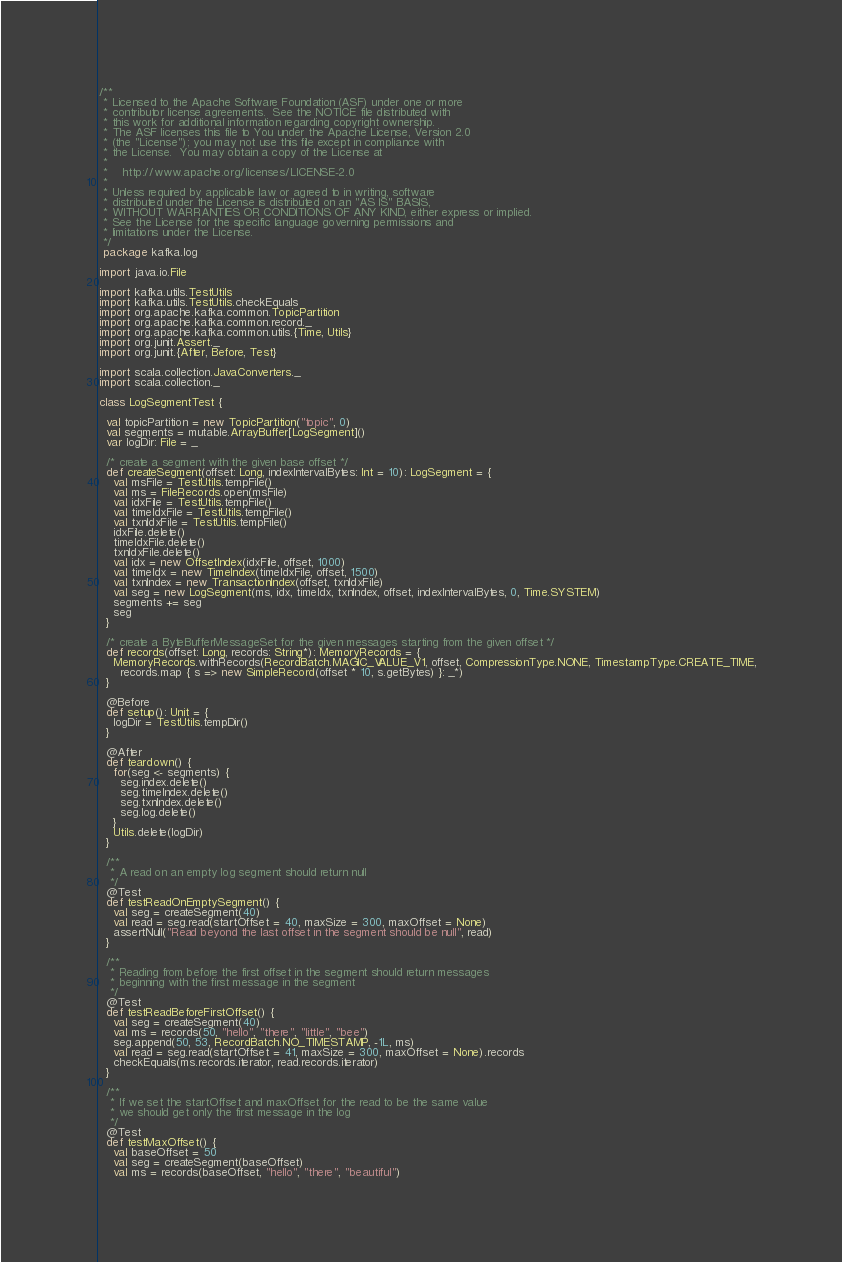Convert code to text. <code><loc_0><loc_0><loc_500><loc_500><_Scala_>/**
 * Licensed to the Apache Software Foundation (ASF) under one or more
 * contributor license agreements.  See the NOTICE file distributed with
 * this work for additional information regarding copyright ownership.
 * The ASF licenses this file to You under the Apache License, Version 2.0
 * (the "License"); you may not use this file except in compliance with
 * the License.  You may obtain a copy of the License at
 *
 *    http://www.apache.org/licenses/LICENSE-2.0
 *
 * Unless required by applicable law or agreed to in writing, software
 * distributed under the License is distributed on an "AS IS" BASIS,
 * WITHOUT WARRANTIES OR CONDITIONS OF ANY KIND, either express or implied.
 * See the License for the specific language governing permissions and
 * limitations under the License.
 */
 package kafka.log

import java.io.File

import kafka.utils.TestUtils
import kafka.utils.TestUtils.checkEquals
import org.apache.kafka.common.TopicPartition
import org.apache.kafka.common.record._
import org.apache.kafka.common.utils.{Time, Utils}
import org.junit.Assert._
import org.junit.{After, Before, Test}

import scala.collection.JavaConverters._
import scala.collection._

class LogSegmentTest {
  
  val topicPartition = new TopicPartition("topic", 0)
  val segments = mutable.ArrayBuffer[LogSegment]()
  var logDir: File = _

  /* create a segment with the given base offset */
  def createSegment(offset: Long, indexIntervalBytes: Int = 10): LogSegment = {
    val msFile = TestUtils.tempFile()
    val ms = FileRecords.open(msFile)
    val idxFile = TestUtils.tempFile()
    val timeIdxFile = TestUtils.tempFile()
    val txnIdxFile = TestUtils.tempFile()
    idxFile.delete()
    timeIdxFile.delete()
    txnIdxFile.delete()
    val idx = new OffsetIndex(idxFile, offset, 1000)
    val timeIdx = new TimeIndex(timeIdxFile, offset, 1500)
    val txnIndex = new TransactionIndex(offset, txnIdxFile)
    val seg = new LogSegment(ms, idx, timeIdx, txnIndex, offset, indexIntervalBytes, 0, Time.SYSTEM)
    segments += seg
    seg
  }
  
  /* create a ByteBufferMessageSet for the given messages starting from the given offset */
  def records(offset: Long, records: String*): MemoryRecords = {
    MemoryRecords.withRecords(RecordBatch.MAGIC_VALUE_V1, offset, CompressionType.NONE, TimestampType.CREATE_TIME,
      records.map { s => new SimpleRecord(offset * 10, s.getBytes) }: _*)
  }

  @Before
  def setup(): Unit = {
    logDir = TestUtils.tempDir()
  }

  @After
  def teardown() {
    for(seg <- segments) {
      seg.index.delete()
      seg.timeIndex.delete()
      seg.txnIndex.delete()
      seg.log.delete()
    }
    Utils.delete(logDir)
  }

  /**
   * A read on an empty log segment should return null
   */
  @Test
  def testReadOnEmptySegment() {
    val seg = createSegment(40)
    val read = seg.read(startOffset = 40, maxSize = 300, maxOffset = None)
    assertNull("Read beyond the last offset in the segment should be null", read)
  }

  /**
   * Reading from before the first offset in the segment should return messages
   * beginning with the first message in the segment
   */
  @Test
  def testReadBeforeFirstOffset() {
    val seg = createSegment(40)
    val ms = records(50, "hello", "there", "little", "bee")
    seg.append(50, 53, RecordBatch.NO_TIMESTAMP, -1L, ms)
    val read = seg.read(startOffset = 41, maxSize = 300, maxOffset = None).records
    checkEquals(ms.records.iterator, read.records.iterator)
  }

  /**
   * If we set the startOffset and maxOffset for the read to be the same value
   * we should get only the first message in the log
   */
  @Test
  def testMaxOffset() {
    val baseOffset = 50
    val seg = createSegment(baseOffset)
    val ms = records(baseOffset, "hello", "there", "beautiful")</code> 